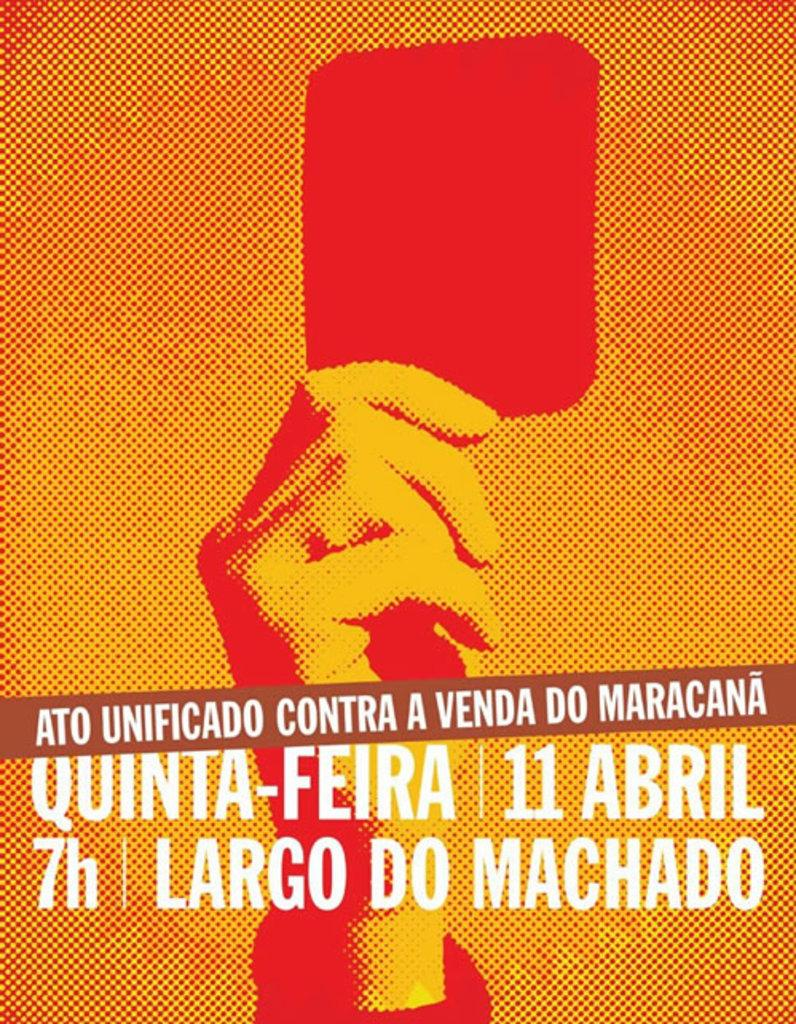<image>
Relay a brief, clear account of the picture shown. a red and orange advertisement for an event on april 11 